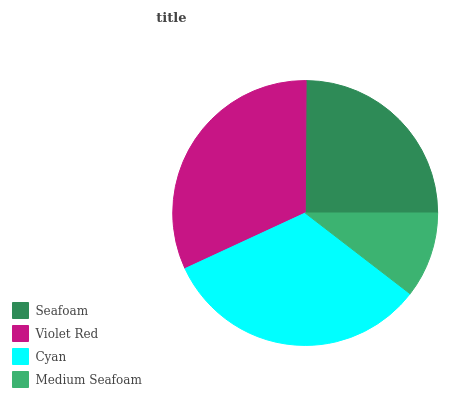Is Medium Seafoam the minimum?
Answer yes or no. Yes. Is Cyan the maximum?
Answer yes or no. Yes. Is Violet Red the minimum?
Answer yes or no. No. Is Violet Red the maximum?
Answer yes or no. No. Is Violet Red greater than Seafoam?
Answer yes or no. Yes. Is Seafoam less than Violet Red?
Answer yes or no. Yes. Is Seafoam greater than Violet Red?
Answer yes or no. No. Is Violet Red less than Seafoam?
Answer yes or no. No. Is Violet Red the high median?
Answer yes or no. Yes. Is Seafoam the low median?
Answer yes or no. Yes. Is Medium Seafoam the high median?
Answer yes or no. No. Is Medium Seafoam the low median?
Answer yes or no. No. 